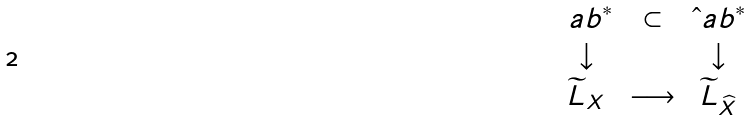Convert formula to latex. <formula><loc_0><loc_0><loc_500><loc_500>\begin{array} { c c c } \ a b ^ { * } & \subset & \hat { \ } a b ^ { * } \\ \downarrow & & \downarrow \\ \widetilde { L } _ { X } & \longrightarrow & \widetilde { L } _ { \widehat { X } } \\ \end{array}</formula> 